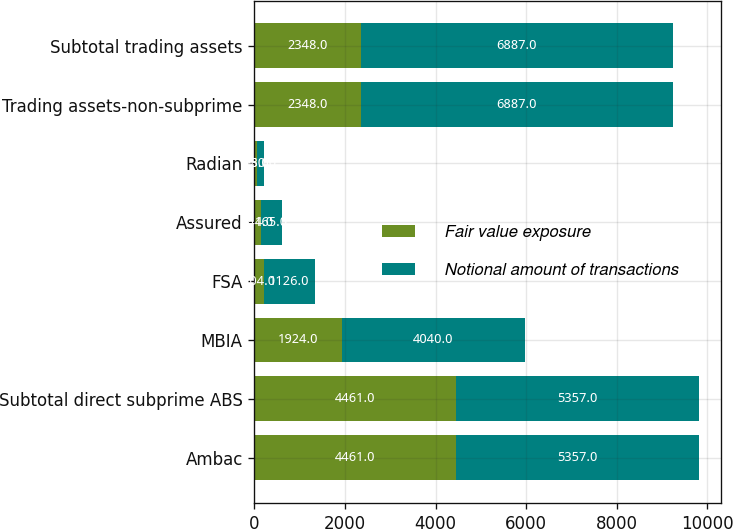<chart> <loc_0><loc_0><loc_500><loc_500><stacked_bar_chart><ecel><fcel>Ambac<fcel>Subtotal direct subprime ABS<fcel>MBIA<fcel>FSA<fcel>Assured<fcel>Radian<fcel>Trading assets-non-subprime<fcel>Subtotal trading assets<nl><fcel>Fair value exposure<fcel>4461<fcel>4461<fcel>1924<fcel>204<fcel>141<fcel>58<fcel>2348<fcel>2348<nl><fcel>Notional amount of transactions<fcel>5357<fcel>5357<fcel>4040<fcel>1126<fcel>465<fcel>150<fcel>6887<fcel>6887<nl></chart> 